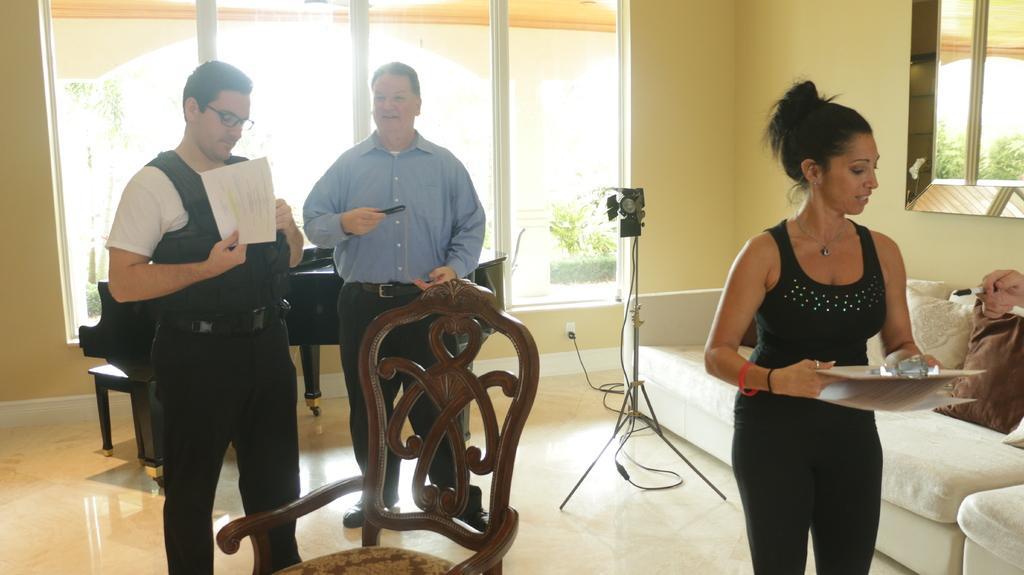Please provide a concise description of this image. In this picture we can see two men and one woman standing holding paper, tray, remote in their hands and beside to them we have camera stand, sofa with pillows on it, chair and at back of them we have window, wall. 